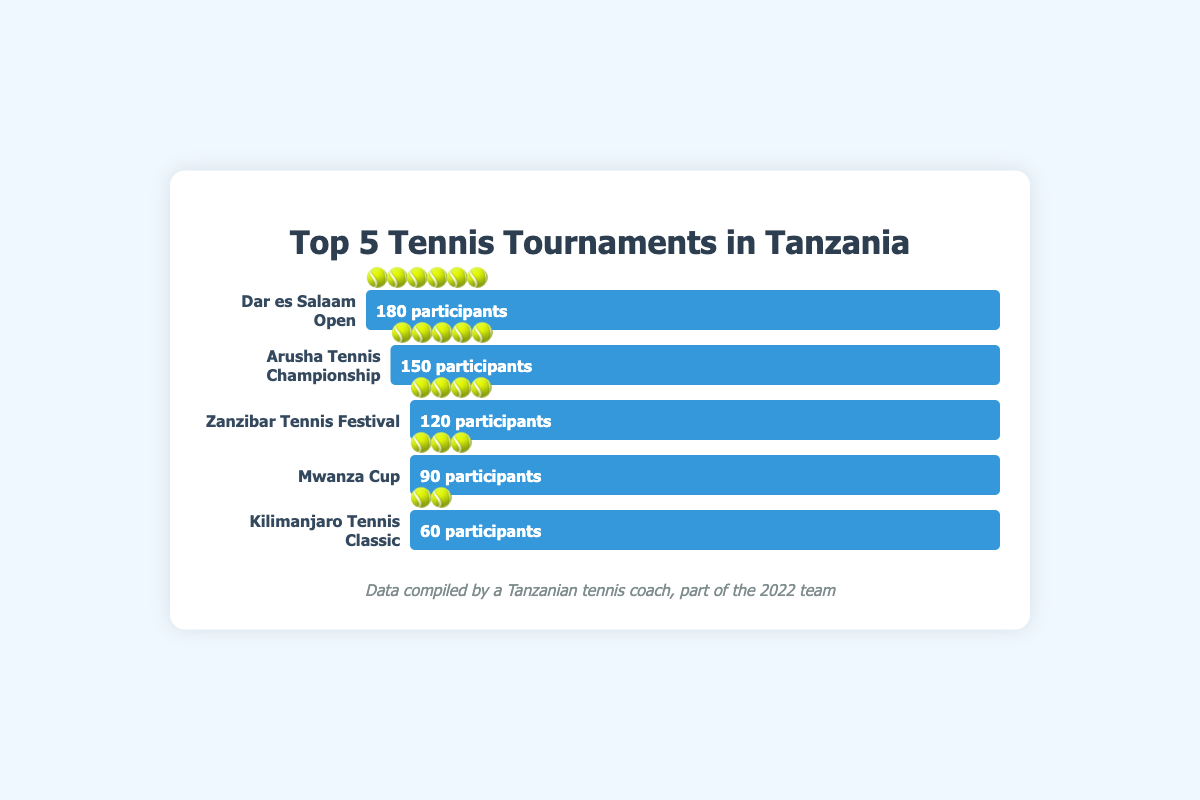What's the title of the figure? The title is typically displayed at the top of the figure, and it is the main heading that describes the content of the figure.
Answer: Top 5 Tennis Tournaments in Tanzania Which tournament has the highest number of participants? The figure shows the number of participants for each tournament represented by the length of the bars. The longest bar corresponds to the Dar es Salaam Open, indicating it has the highest number of participants.
Answer: Dar es Salaam Open How many participants does the Arusha Tennis Championship have? The Arusha Tennis Championship is represented by the second bar from the top. The label next to the bar shows the exact number of participants.
Answer: 150 participants Compare the number of participants between the Zanzibar Tennis Festival and the Mwanza Cup. The Zanzibar Tennis Festival is represented by the third bar, while the Mwanza Cup is the fourth bar. The Zanzibar Tennis Festival has 30 more participants than the Mwanza Cup (120 - 90).
Answer: Zanzibar Tennis Festival has 30 more participants What's the combined total number of participants for Mwanza Cup and Kilimanjaro Tennis Classic? The number of participants for Mwanza Cup is 90, and for Kilimanjaro Tennis Classic is 60. Adding these together gives 90 + 60 = 150.
Answer: 150 participants What's the difference in the number of participants between the Dar es Salaam Open and the Kilimanjaro Tennis Classic? The Dar es Salaam Open has 180 participants and the Kilimanjaro Tennis Classic has 60 participants. The difference is 180 - 60 = 120.
Answer: 120 participants Which tournament has the smallest number of participants and how many? The smallest bar corresponds to the Kilimanjaro Tennis Classic, which has the fewest participants at 60.
Answer: Kilimanjaro Tennis Classic, 60 participants How are the participants represented visually in the chart? The participants are depicted using both the length of the bars and emojis. Each bar's length is proportional to the number of participants and each emoji (🎾) represents roughly 30 participants.
Answer: Bars and 🎾 emojis Rank the tournaments by the number of participants from highest to lowest. Observing the lengths of the bars from top to bottom: 1. Dar es Salaam Open, 2. Arusha Tennis Championship, 3. Zanzibar Tennis Festival, 4. Mwanza Cup, 5. Kilimanjaro Tennis Classic.
Answer: Dar es Salaam Open, Arusha Tennis Championship, Zanzibar Tennis Festival, Mwanza Cup, Kilimanjaro Tennis Classic How many more participants does the Zanzibar Tennis Festival need to match the participants of Dar es Salaam Open? Dar es Salaam Open has 180 participants and Zanzibar Tennis Festival has 120. The difference is 180 - 120 = 60.
Answer: 60 participants 